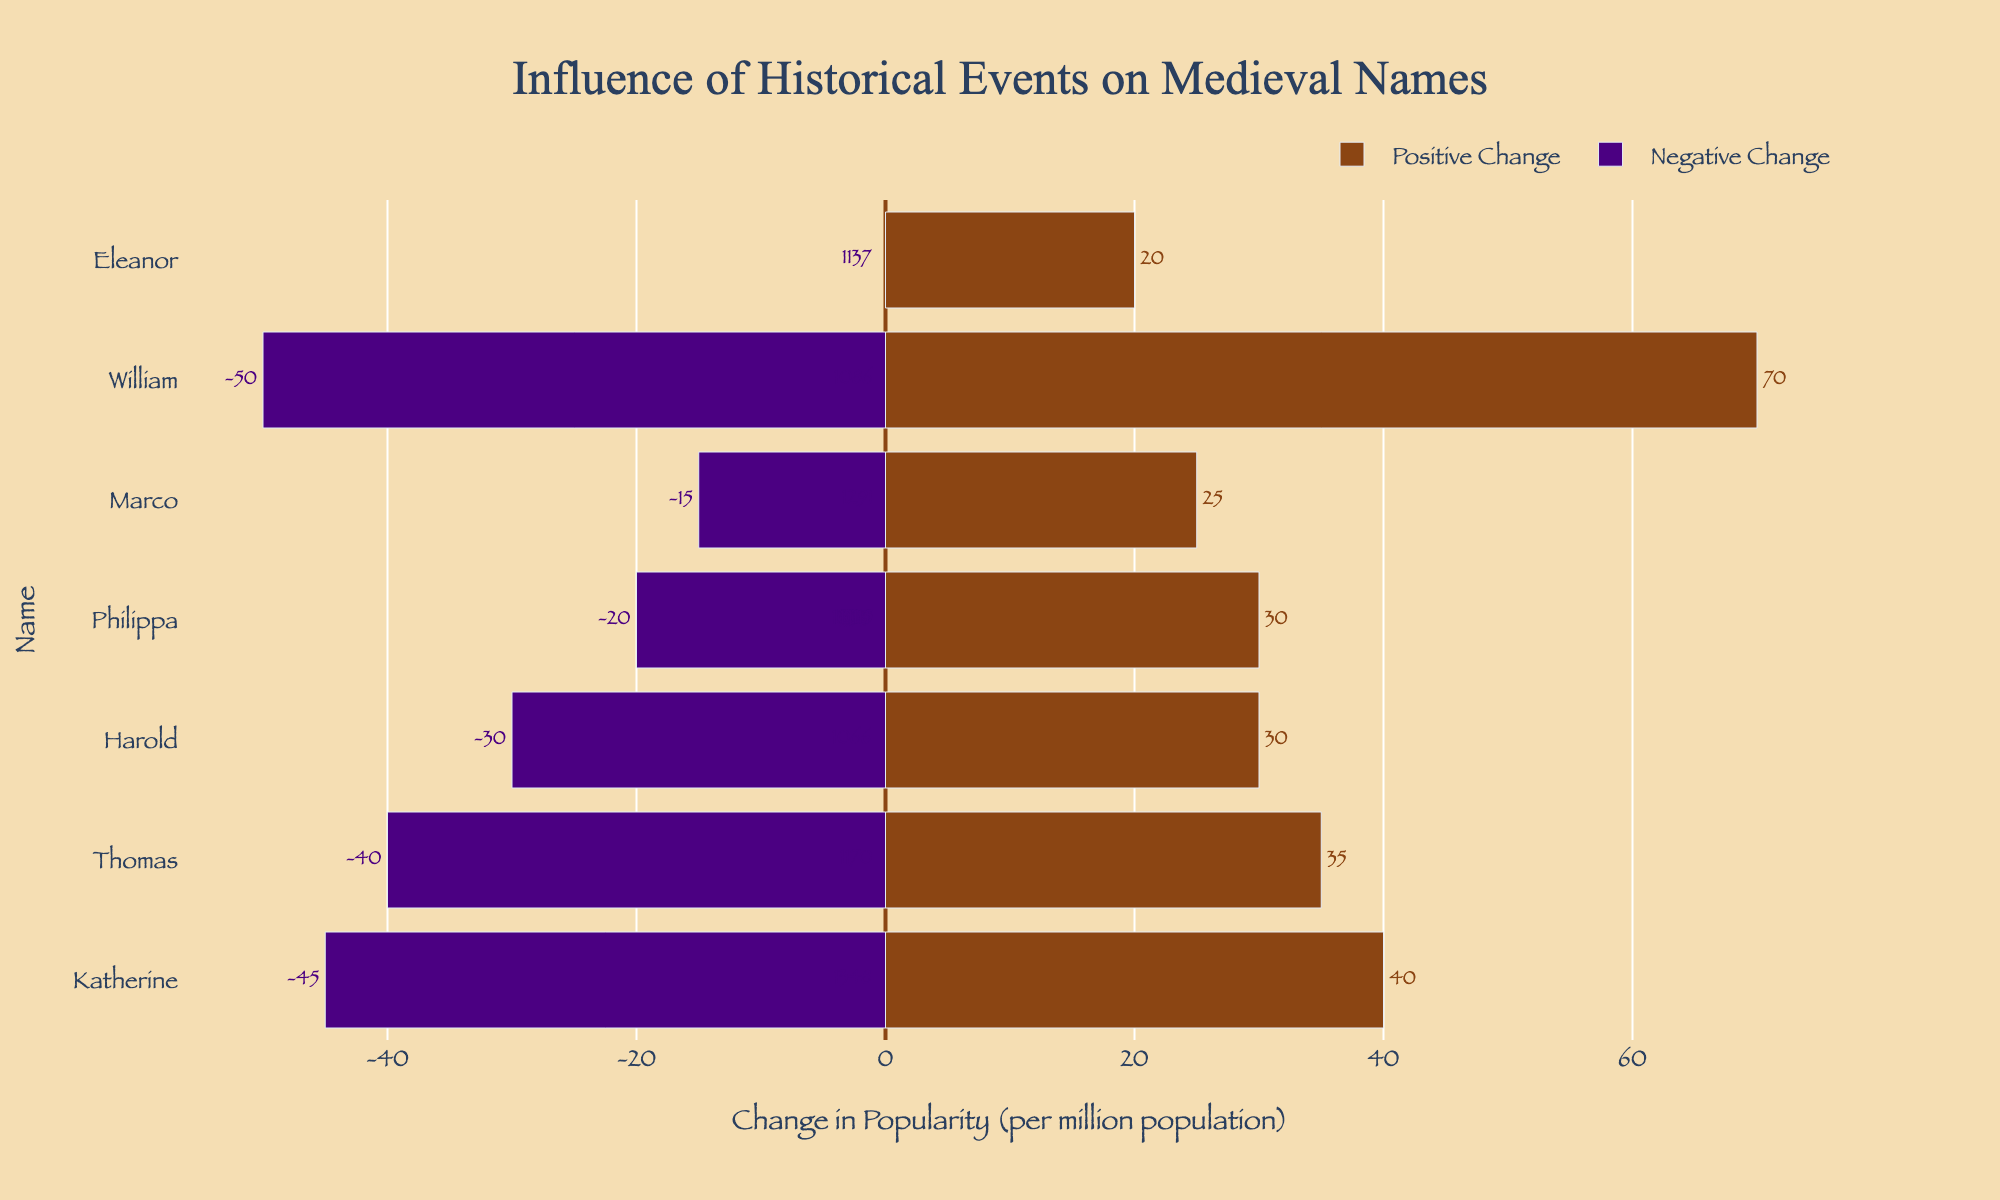What name experienced the largest positive change due to historical events? First, identify the bar with the greatest positive extension. The name "William" shows the highest positive change with 70.
Answer: William What is the combined total change in name popularity for names "Thomas" and "Katherine"? Find the changes for "Thomas" (-45) and "Katherine" (-50) and sum them up. -45 + (-50) = -95.
Answer: -95 Which name had a 40-unit decrease in popularity due to historical events? Look at the bars representing negative changes and find the one with -40. "Harold" has a 40-unit decrease.
Answer: Harold How many names had a decrease in popularity due to historical events? Count the number of names with bars extending to the left of zero (negative changes). There are six: Harold, Adelaide, Thomas, John, Robert, Katherine.
Answer: Six What is the average positive change in popularity for names due to historical events? Sum all the positive changes (70 + 20 + 30 + 25 + 35 + 40 + 30 = 250) and divide by the number of positive changes (7). 250/7 ≈ 35.71.
Answer: 35.71 Which name and event resulted in a negative change of more than 40 units but less than 50 units? Identify a name with a negative change fitting the criteria. "Thomas" experienced a 45-unit decrease.
Answer: Thomas What is the total change in name popularity for all names from England? Add both positive and negative changes for names from England: -40 (Harold) + 70 (William) - 45 (Thomas) - 30 (John) + 40 (Philippa) - 50 (Katherine). -40 + 70 - 45 - 30 + 40 - 50 = -55.
Answer: -55 Which name had the smallest absolute change in popularity due to historical events? Look for the name with the smallest bar either positively or negatively. "Adelaide" experienced a -15 change, which is the smallest absolute change.
Answer: Adelaide Compare the change in popularity between "Marco" and "Francis." Who had a greater positive change? "Marco" increased by 35 units, whereas "Francis" increased by 25 units. Compare both.
Answer: Marco Which historical event caused the highest decrease in name popularity? The bar with the longest extension in the negative direction shows. "Katherine" experienced a 50-unit decrease.
Answer: Katherine 